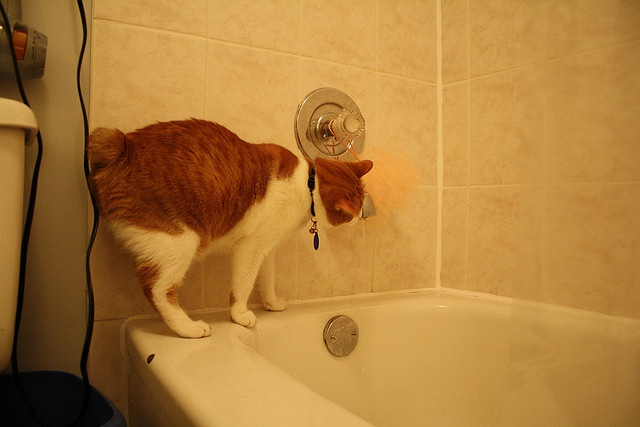Describe the objects in this image and their specific colors. I can see cat in black, maroon, orange, and brown tones and toilet in black, olive, tan, and maroon tones in this image. 